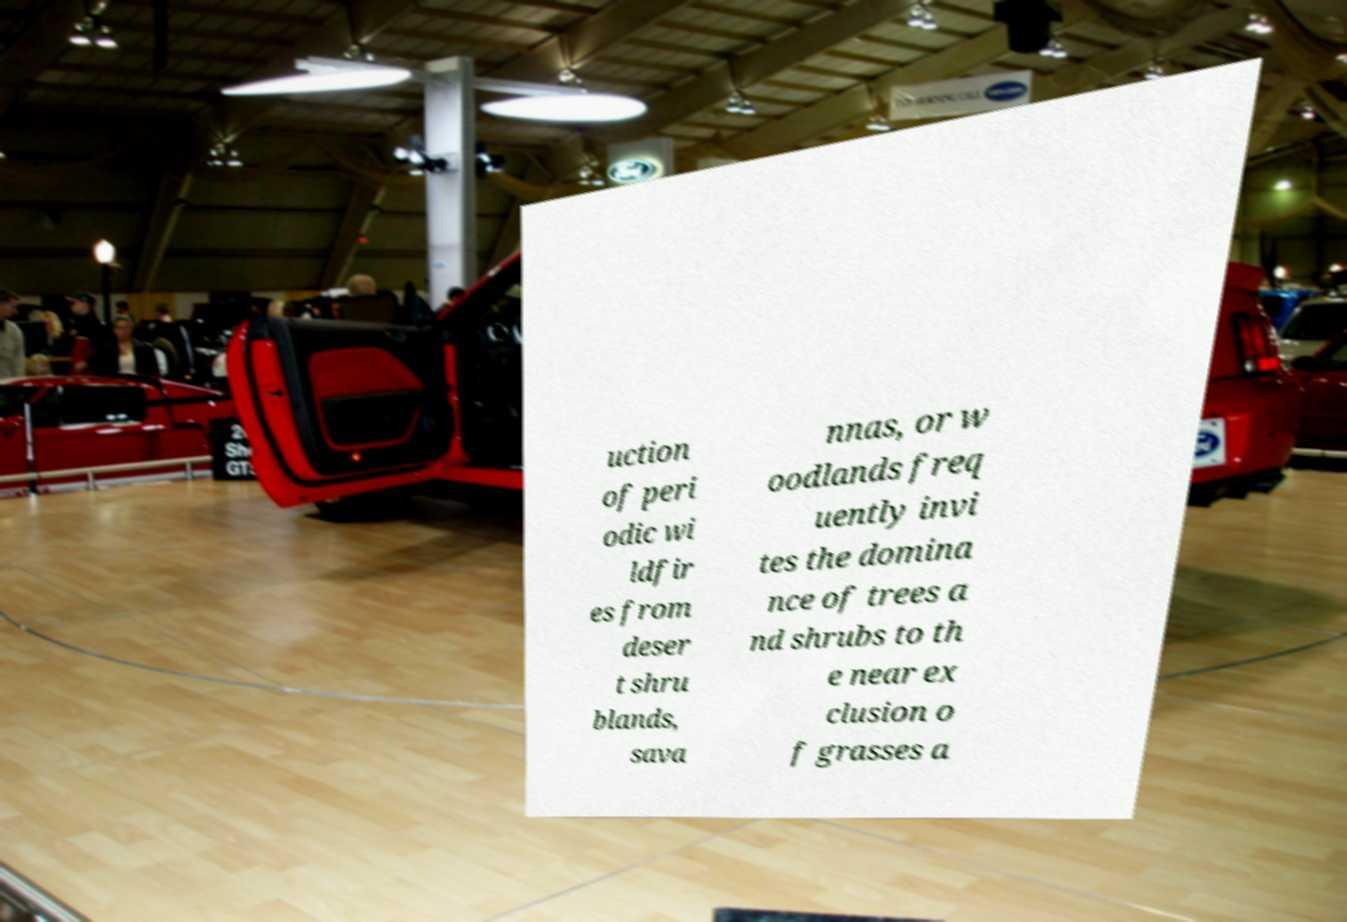Can you accurately transcribe the text from the provided image for me? uction of peri odic wi ldfir es from deser t shru blands, sava nnas, or w oodlands freq uently invi tes the domina nce of trees a nd shrubs to th e near ex clusion o f grasses a 